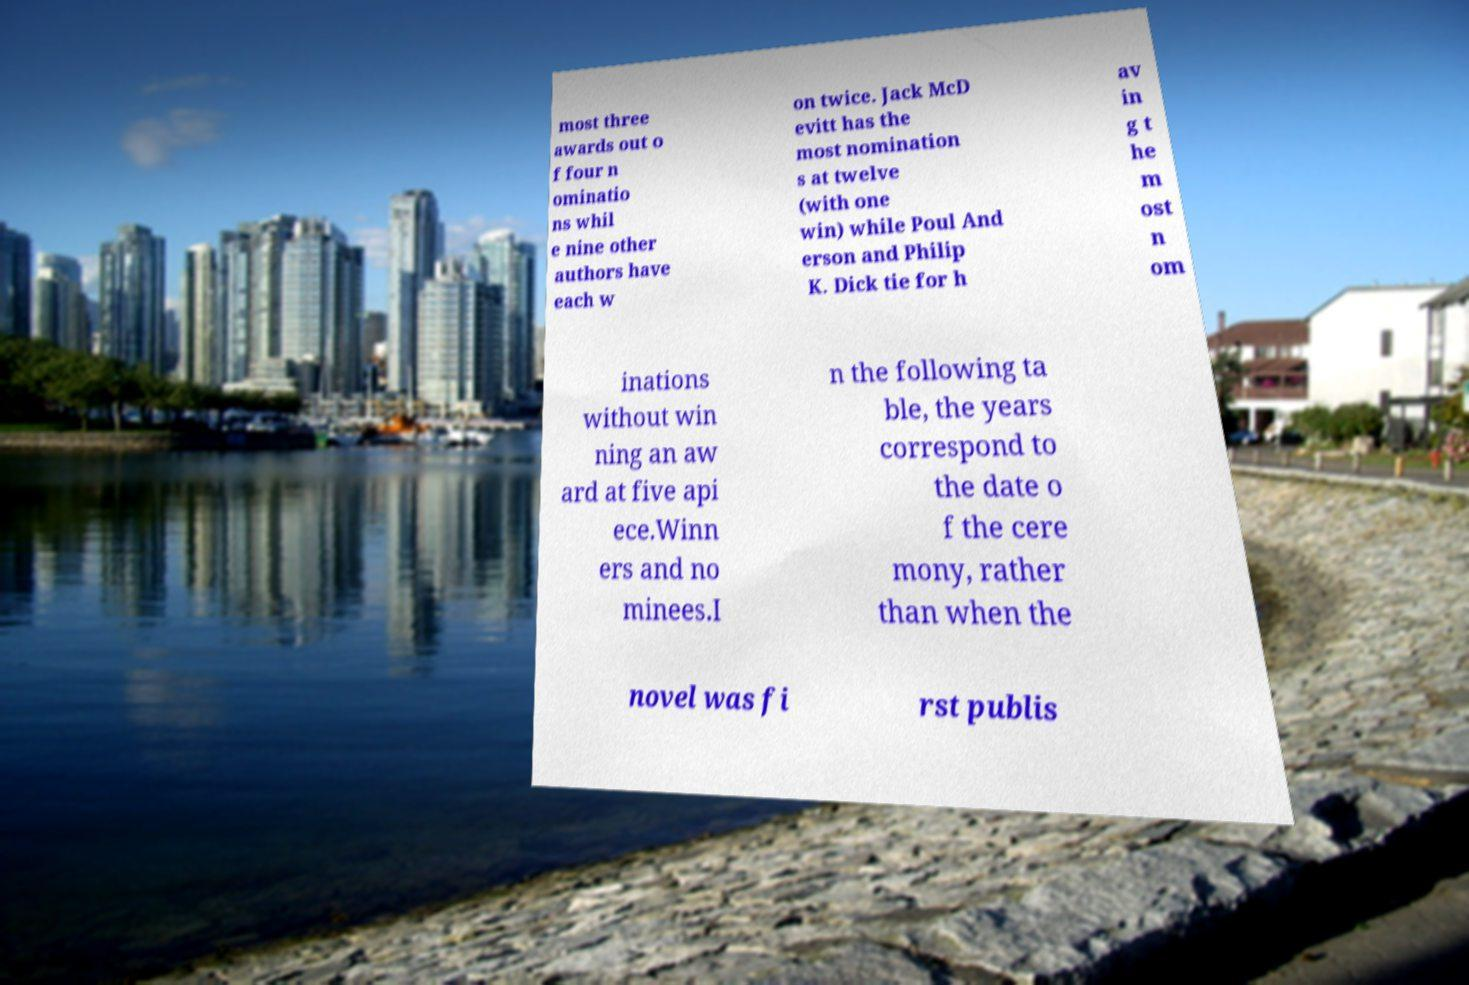Can you accurately transcribe the text from the provided image for me? most three awards out o f four n ominatio ns whil e nine other authors have each w on twice. Jack McD evitt has the most nomination s at twelve (with one win) while Poul And erson and Philip K. Dick tie for h av in g t he m ost n om inations without win ning an aw ard at five api ece.Winn ers and no minees.I n the following ta ble, the years correspond to the date o f the cere mony, rather than when the novel was fi rst publis 